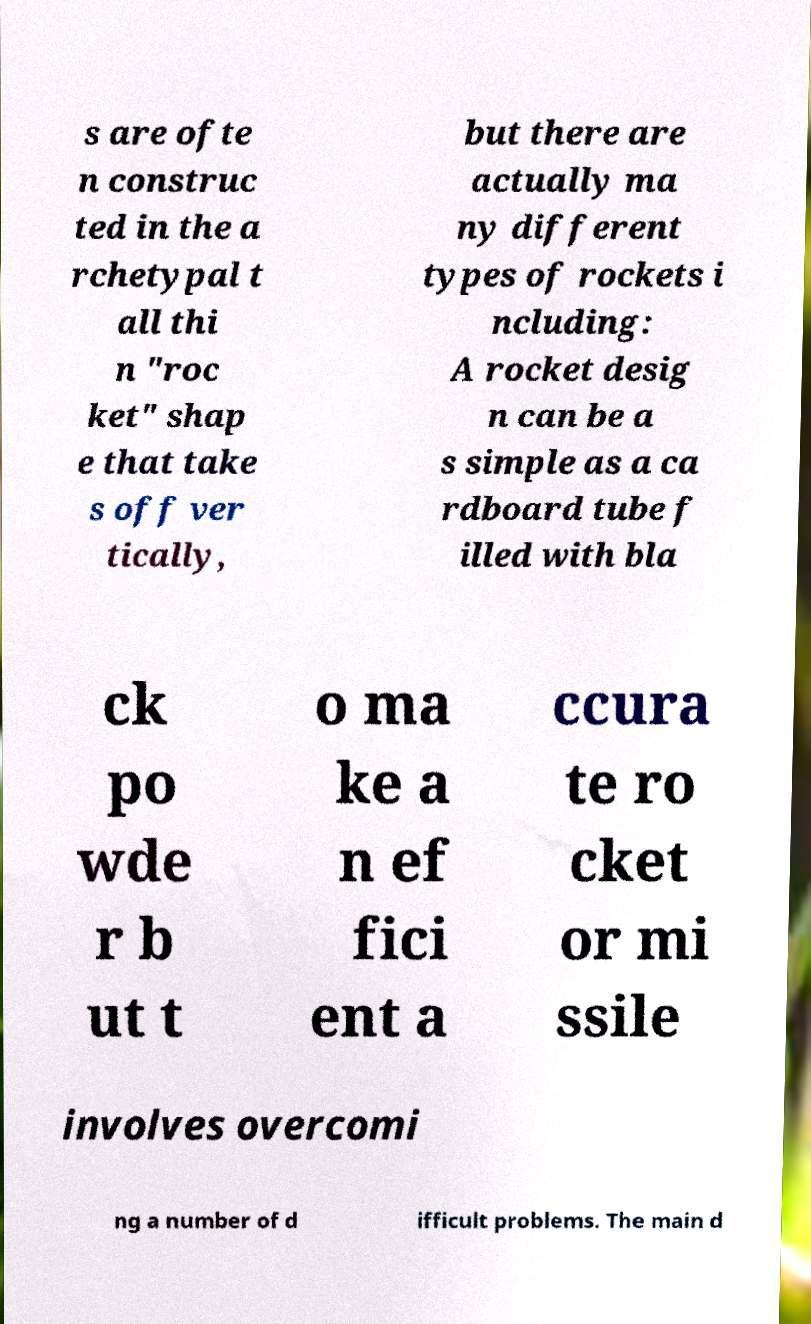Can you accurately transcribe the text from the provided image for me? s are ofte n construc ted in the a rchetypal t all thi n "roc ket" shap e that take s off ver tically, but there are actually ma ny different types of rockets i ncluding: A rocket desig n can be a s simple as a ca rdboard tube f illed with bla ck po wde r b ut t o ma ke a n ef fici ent a ccura te ro cket or mi ssile involves overcomi ng a number of d ifficult problems. The main d 